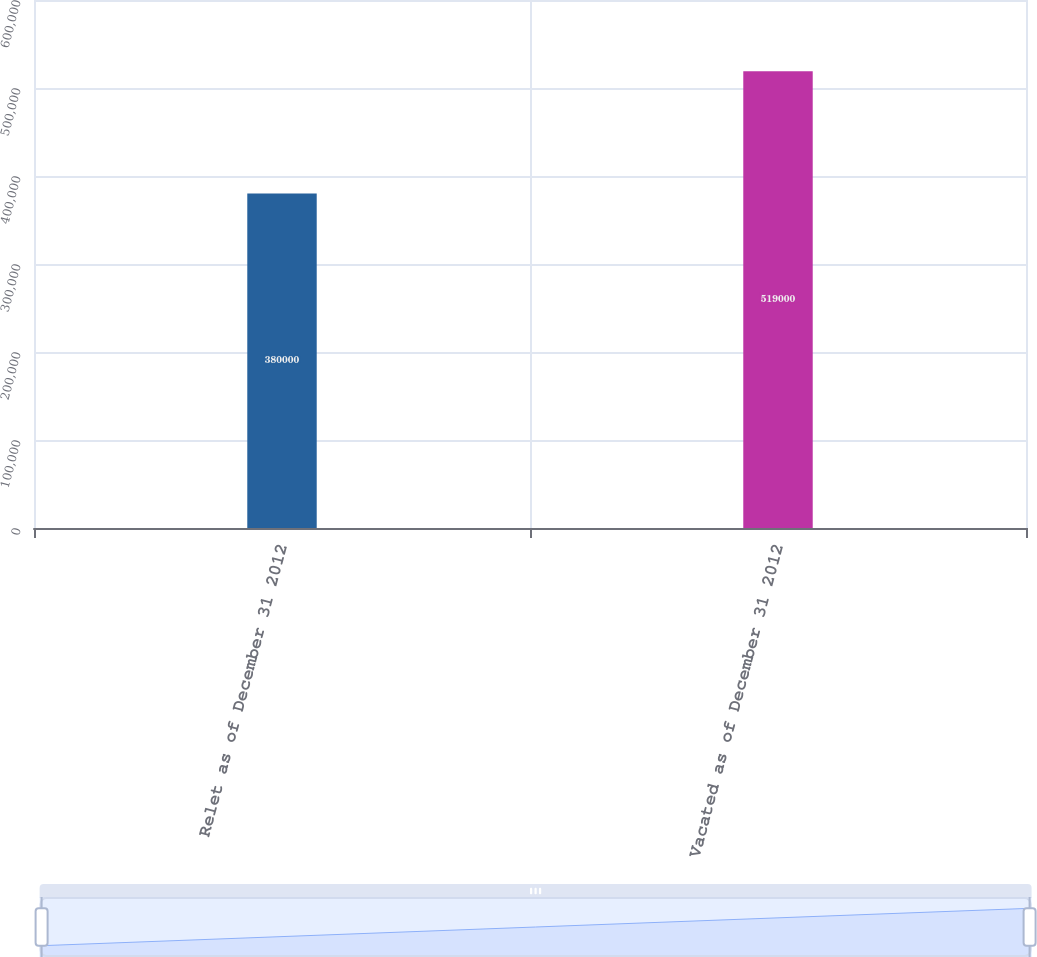<chart> <loc_0><loc_0><loc_500><loc_500><bar_chart><fcel>Relet as of December 31 2012<fcel>Vacated as of December 31 2012<nl><fcel>380000<fcel>519000<nl></chart> 